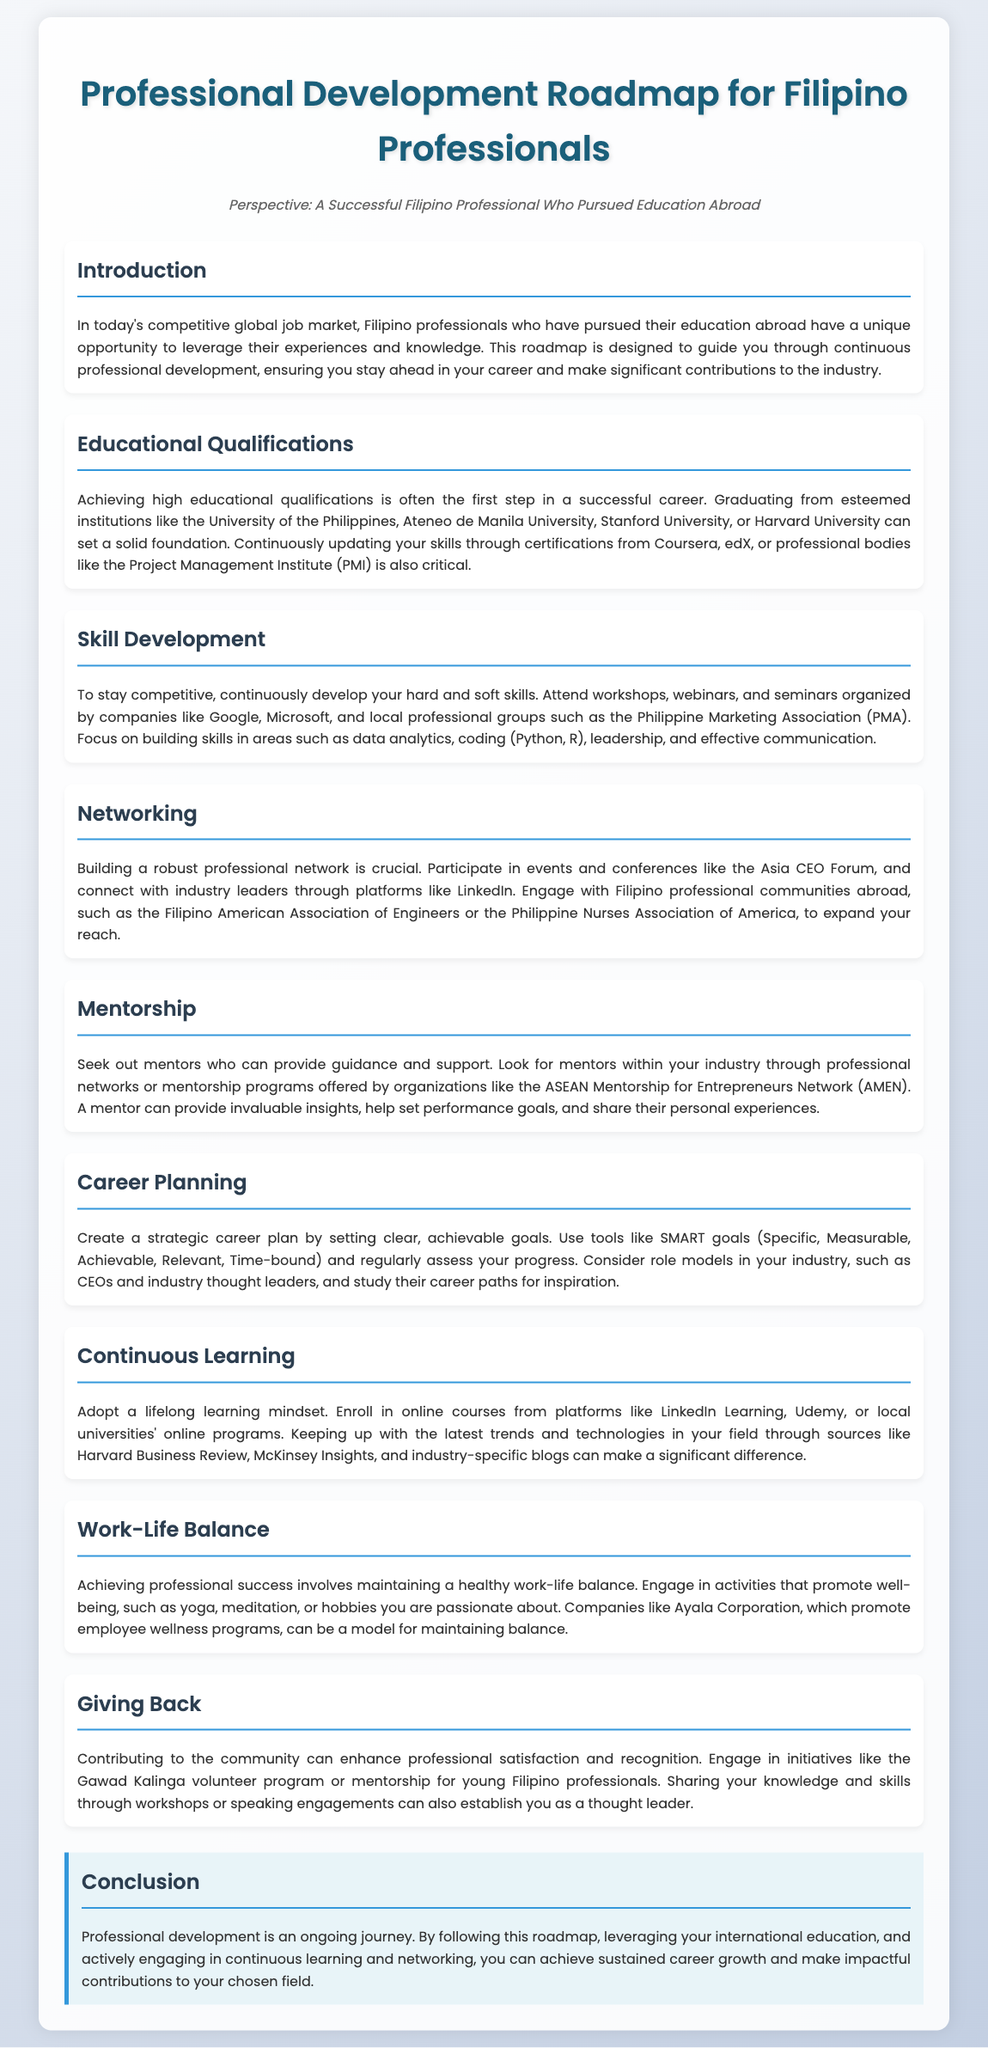What is the primary focus of the roadmap? The roadmap is designed to guide you through continuous professional development for Filipino professionals.
Answer: Continuous professional development Which institutions are mentioned for high educational qualifications? The document lists institutions that are essential for building a solid foundation in one's career, such as the University of the Philippines and Stanford University.
Answer: University of the Philippines, Ateneo de Manila University, Stanford University, Harvard University What type of skills should be developed according to the document? It states that professionals should develop both hard and soft skills, with specific examples mentioned.
Answer: Hard and soft skills What is the purpose of networking as per the roadmap? The document emphasizes the importance of networking for building a robust professional network.
Answer: Building a robust professional network Which platform is recommended for connecting with industry leaders? It suggests a specific social media platform that is popular for professional networking.
Answer: LinkedIn What type of goals should be set for career planning? The document introduces a specific framework for creating strategic career plans.
Answer: SMART goals Which organization offers mentorship programs mentioned in the roadmap? It references an organization that provides mentorship opportunities to professionals.
Answer: ASEAN Mentorship for Entrepreneurs Network Name one company mentioned that promotes employee wellness programs. The document points to a specific company known for its initiatives in employee wellness.
Answer: Ayala Corporation What is the benefit of contributing to the community according to the document? It states that community engagement can enhance a certain professional aspect.
Answer: Professional satisfaction and recognition 